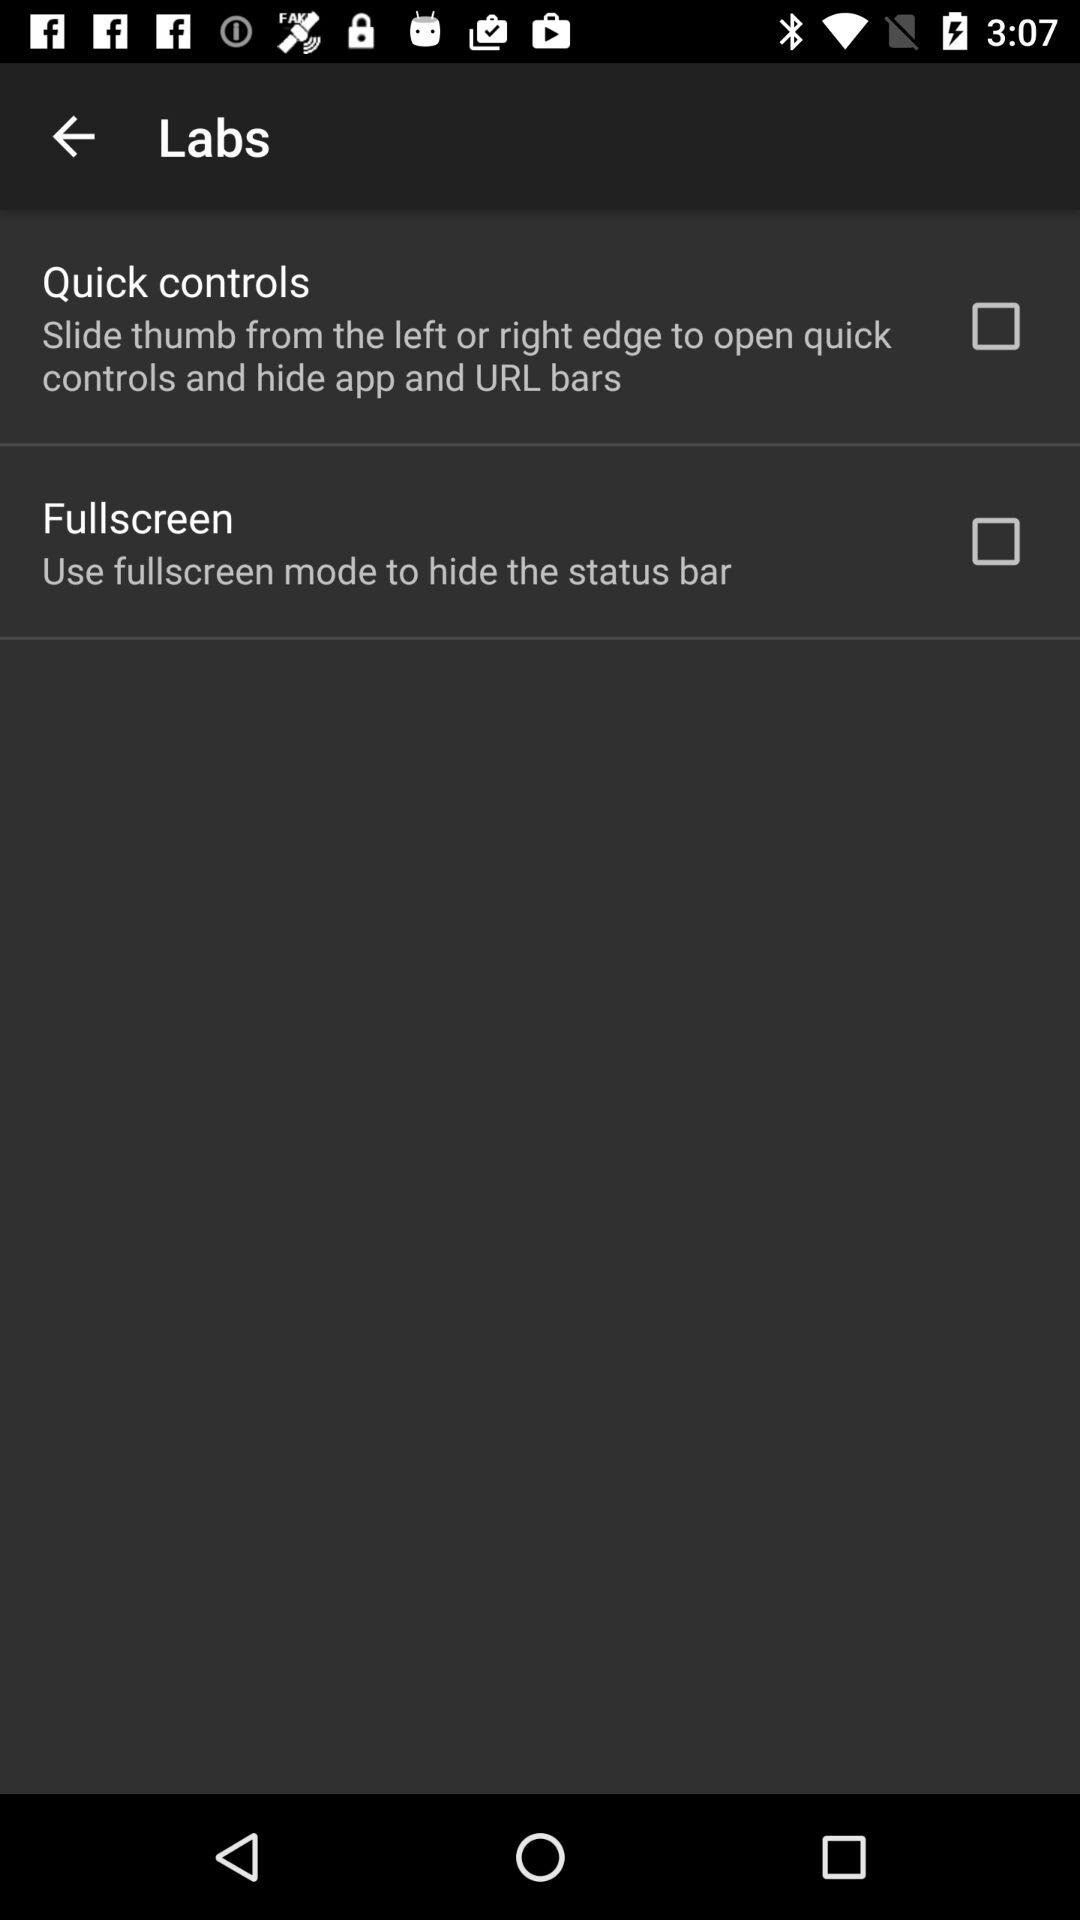How many features are available in the Labs tab?
Answer the question using a single word or phrase. 2 